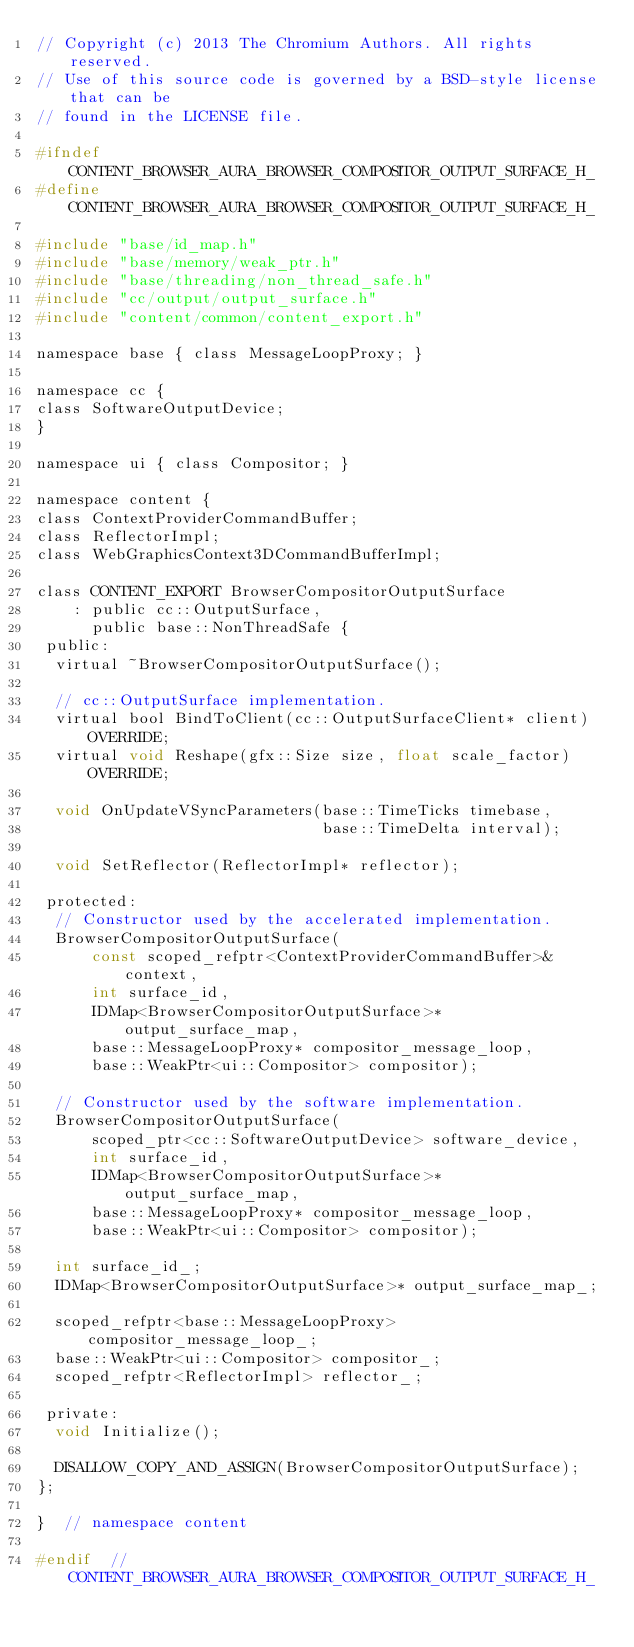Convert code to text. <code><loc_0><loc_0><loc_500><loc_500><_C_>// Copyright (c) 2013 The Chromium Authors. All rights reserved.
// Use of this source code is governed by a BSD-style license that can be
// found in the LICENSE file.

#ifndef CONTENT_BROWSER_AURA_BROWSER_COMPOSITOR_OUTPUT_SURFACE_H_
#define CONTENT_BROWSER_AURA_BROWSER_COMPOSITOR_OUTPUT_SURFACE_H_

#include "base/id_map.h"
#include "base/memory/weak_ptr.h"
#include "base/threading/non_thread_safe.h"
#include "cc/output/output_surface.h"
#include "content/common/content_export.h"

namespace base { class MessageLoopProxy; }

namespace cc {
class SoftwareOutputDevice;
}

namespace ui { class Compositor; }

namespace content {
class ContextProviderCommandBuffer;
class ReflectorImpl;
class WebGraphicsContext3DCommandBufferImpl;

class CONTENT_EXPORT BrowserCompositorOutputSurface
    : public cc::OutputSurface,
      public base::NonThreadSafe {
 public:
  virtual ~BrowserCompositorOutputSurface();

  // cc::OutputSurface implementation.
  virtual bool BindToClient(cc::OutputSurfaceClient* client) OVERRIDE;
  virtual void Reshape(gfx::Size size, float scale_factor) OVERRIDE;

  void OnUpdateVSyncParameters(base::TimeTicks timebase,
                               base::TimeDelta interval);

  void SetReflector(ReflectorImpl* reflector);

 protected:
  // Constructor used by the accelerated implementation.
  BrowserCompositorOutputSurface(
      const scoped_refptr<ContextProviderCommandBuffer>& context,
      int surface_id,
      IDMap<BrowserCompositorOutputSurface>* output_surface_map,
      base::MessageLoopProxy* compositor_message_loop,
      base::WeakPtr<ui::Compositor> compositor);

  // Constructor used by the software implementation.
  BrowserCompositorOutputSurface(
      scoped_ptr<cc::SoftwareOutputDevice> software_device,
      int surface_id,
      IDMap<BrowserCompositorOutputSurface>* output_surface_map,
      base::MessageLoopProxy* compositor_message_loop,
      base::WeakPtr<ui::Compositor> compositor);

  int surface_id_;
  IDMap<BrowserCompositorOutputSurface>* output_surface_map_;

  scoped_refptr<base::MessageLoopProxy> compositor_message_loop_;
  base::WeakPtr<ui::Compositor> compositor_;
  scoped_refptr<ReflectorImpl> reflector_;

 private:
  void Initialize();

  DISALLOW_COPY_AND_ASSIGN(BrowserCompositorOutputSurface);
};

}  // namespace content

#endif  // CONTENT_BROWSER_AURA_BROWSER_COMPOSITOR_OUTPUT_SURFACE_H_
</code> 